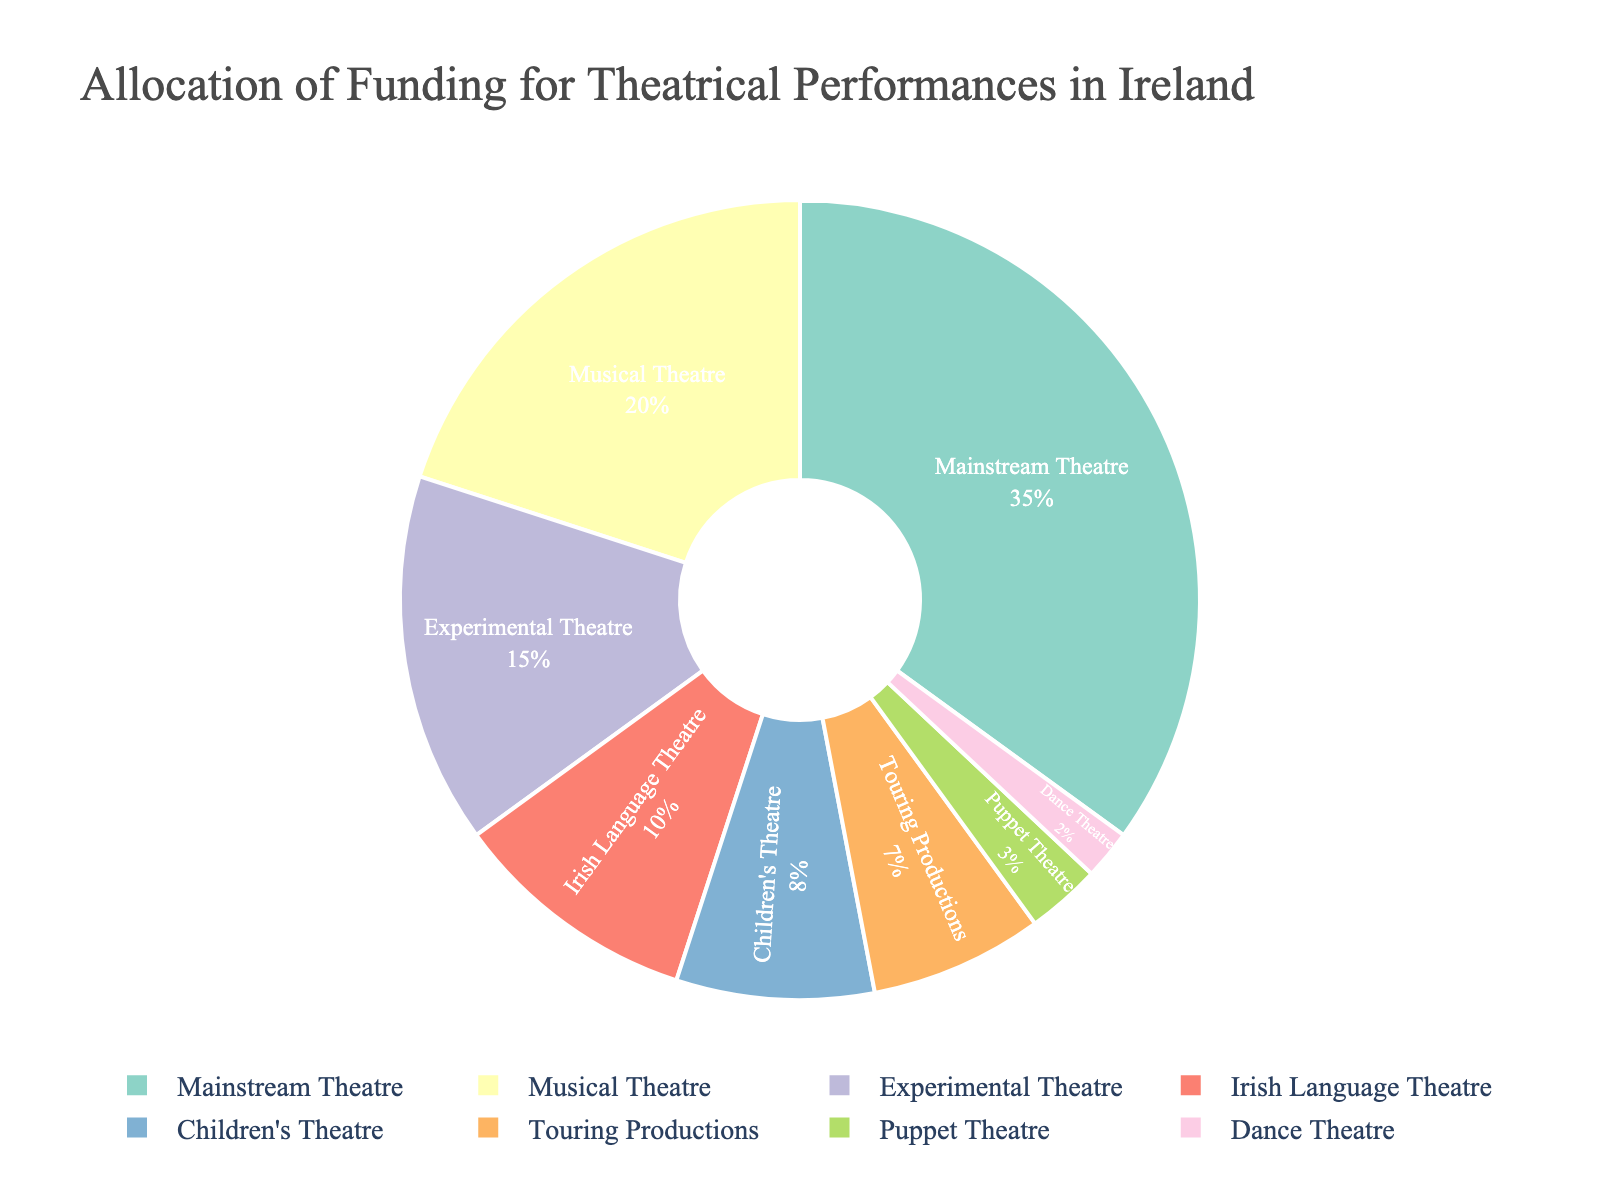How much more funding is allocated to Mainstream Theatre compared to Dance Theatre? First, find the percentage for Mainstream Theatre, which is 35%. Then, find the percentage for Dance Theatre, which is 2%. Subtract the Dance Theatre percentage from the Mainstream Theatre percentage: 35 - 2 = 33%
Answer: 33% Which type of theatrical performance receives the least amount of funding? Look at the pie chart and identify the category with the smallest slice. Puppet Theatre has the smallest slice, which corresponds to 3%.
Answer: Puppet Theatre What is the combined percentage of funding for Experimental Theatre and Musical Theatre? Find the percentages for both Experimental Theatre and Musical Theatre, which are 15% and 20% respectively. Add these two percentages together: 15 + 20 = 35%
Answer: 35% Does Children's Theatre receive more funding than Touring Productions? Compare the percentages for both categories. Children's Theatre receives 8% while Touring Productions receives 7%. Since 8 is greater than 7, the answer is yes.
Answer: Yes What is the total percentage of funding allocated to Irish Language Theatre, Children's Theatre, and Puppet Theatre combined? Sum up the percentages for Irish Language Theatre (10%), Children's Theatre (8%), and Puppet Theatre (3%): 10 + 8 + 3 = 21%
Answer: 21% How many categories receive more funding than Children's Theatre? Identify categories with a higher percentage than Children's Theatre, which is 8%. Mainstream Theatre (35%), Experimental Theatre (15%), and Musical Theatre (20%) are the categories that receive more funding. There are 3 such categories.
Answer: 3 What is the difference in funding percentage between Musical Theatre and Touring Productions? Find and subtract the percentages for both categories: Musical Theatre (20%) and Touring Productions (7%). Subtract 7 from 20: 20 - 7 = 13%
Answer: 13% Which category has the third highest percentage of funding? Identify and rank the top percentages, then find the third highest. The percentages are: Mainstream Theatre (35%), Musical Theatre (20%), and Experimental Theatre (15%). The third highest is Experimental Theatre at 15%.
Answer: Experimental Theatre What is the visual color used for representing Mainstream Theatre in the pie chart? Look at the pie chart and identify the color used for Mainstream Theatre. This question relies on visual inspection of the chart
Answer: Please refer to the chart If the funding percentage for Experimental Theatre increased by 5%, what would the new percentage be? Add the increase to the current percentage of Experimental Theatre: 15% + 5% = 20%
Answer: 20% 